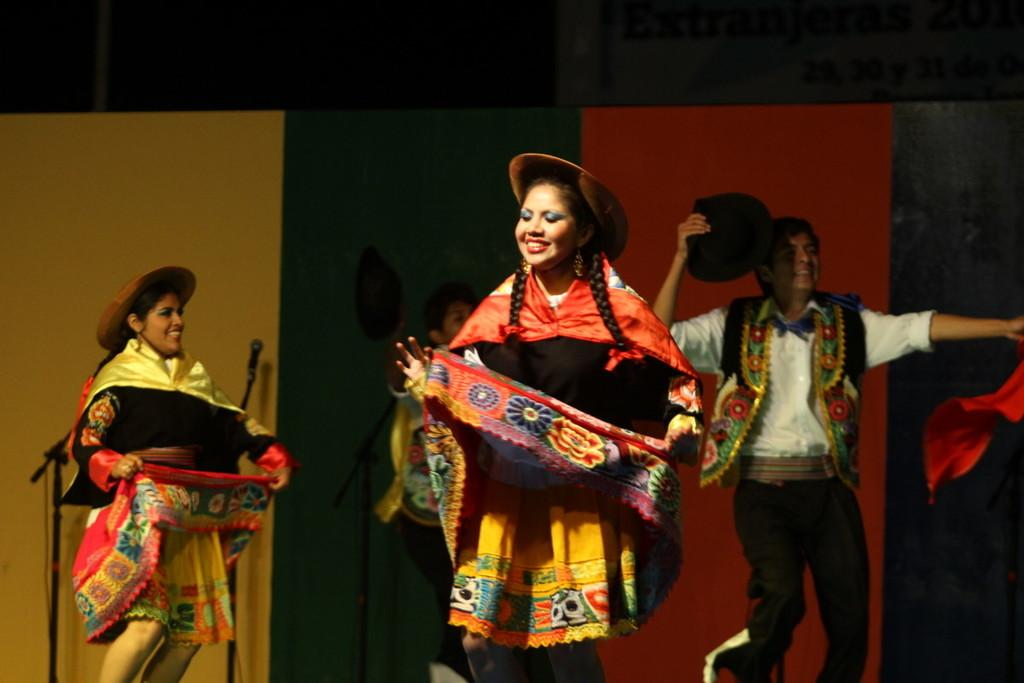What are the people in the image doing? The people in the image are dancing. What accessories can be seen on the people in the image? There are hats visible in the image. What equipment is present in the image for amplifying sound? There is a microphone with a stand in the image. What book is the mother reading to the children in the bedroom in the image? There is no mother, children, or bedroom present in the image. The image features people dancing with hats and a microphone with a stand. 